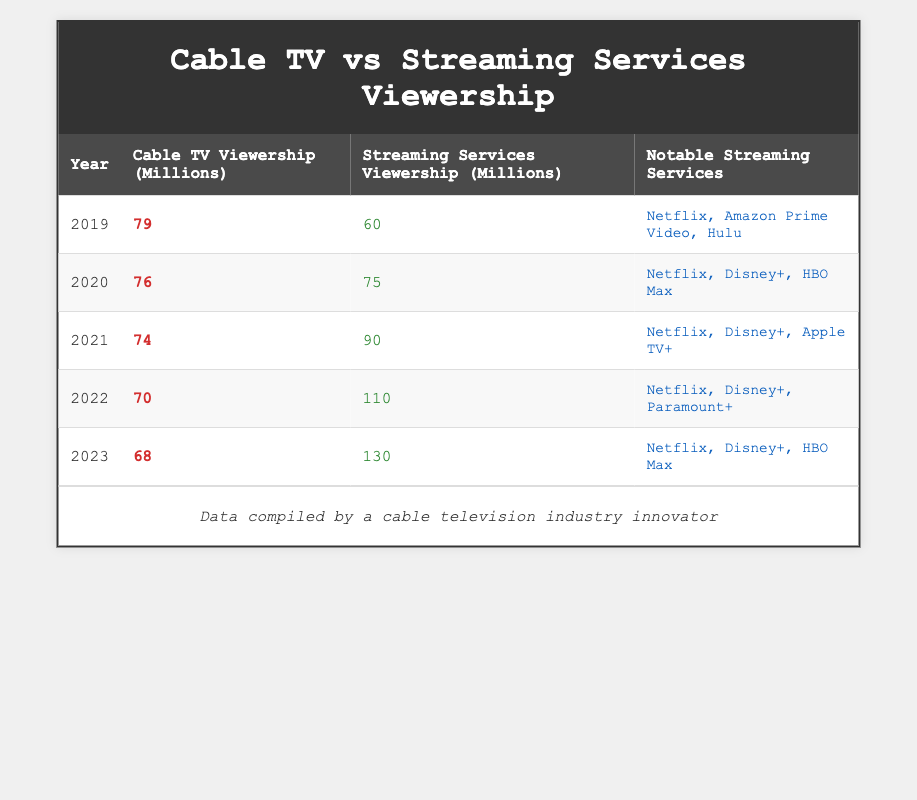What was the cable TV viewership in 2020? In the year 2020, the table indicates that the cable TV viewership was 76 million.
Answer: 76 million In which year did streaming services first exceed cable TV viewership? By observing the data, the first year where streaming services viewership exceeded cable TV viewership is 2021, where streaming had 90 million versus cable's 74 million.
Answer: 2021 What is the total cable TV viewership from 2019 to 2023? To find the total cable TV viewership, sum the values for each year: 79 + 76 + 74 + 70 + 68 = 367 million.
Answer: 367 million Is it true that the notable streaming services in 2022 included both Netflix and Disney+? By examining the notable streaming services for the year 2022, we see that both Netflix and Disney+ are listed as notable services.
Answer: Yes What is the percentage decrease in cable TV viewership from 2019 to 2023? For the percentage decrease, calculate the difference between the viewership in 2019 and 2023: (79 - 68) = 11 million. Then divide by the 2019 value (79): (11 / 79) * 100 ≈ 13.92%.
Answer: Approximately 13.92% 